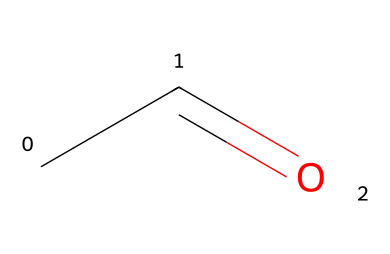What is the name of this chemical? The structure CC=O represents acetaldehyde, which is a simple aldehyde with a carbonyl functional group.
Answer: acetaldehyde How many carbon atoms are in the structure? The SMILES representation CC=O has two carbon atoms (C, C) connected to an oxygen atom through a double bond.
Answer: two What functional group is present in this molecule? The formula includes a carbonyl group (C=O), which characterizes aldehydes, specifically the aldehyde functional group.
Answer: aldehyde What is the total number of hydrogen atoms in acetaldehyde? The molecular formula derived from the SMILES CC=O indicates two carbon atoms and one oxygen atom with a total of four hydrogen atoms to satisfy the valency of carbon.
Answer: four What type of reaction typically produces acetaldehyde? Acetaldehyde is typically produced through fermentation processes, particularly in the production of alcohol where sugars are converted.
Answer: fermentation Why does acetaldehyde have a strong odor? The structure indicates a small aldehyde with a simple carbon backbone, and aldehydes are known to exhibit strong, sometimes pungent odors due to their volatility and reactivity.
Answer: strong odor 